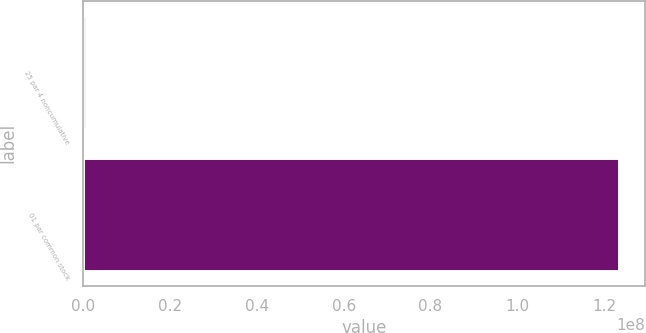Convert chart. <chart><loc_0><loc_0><loc_500><loc_500><bar_chart><fcel>25 par 4 noncumulative<fcel>01 par common stock<nl><fcel>649736<fcel>1.23352e+08<nl></chart> 